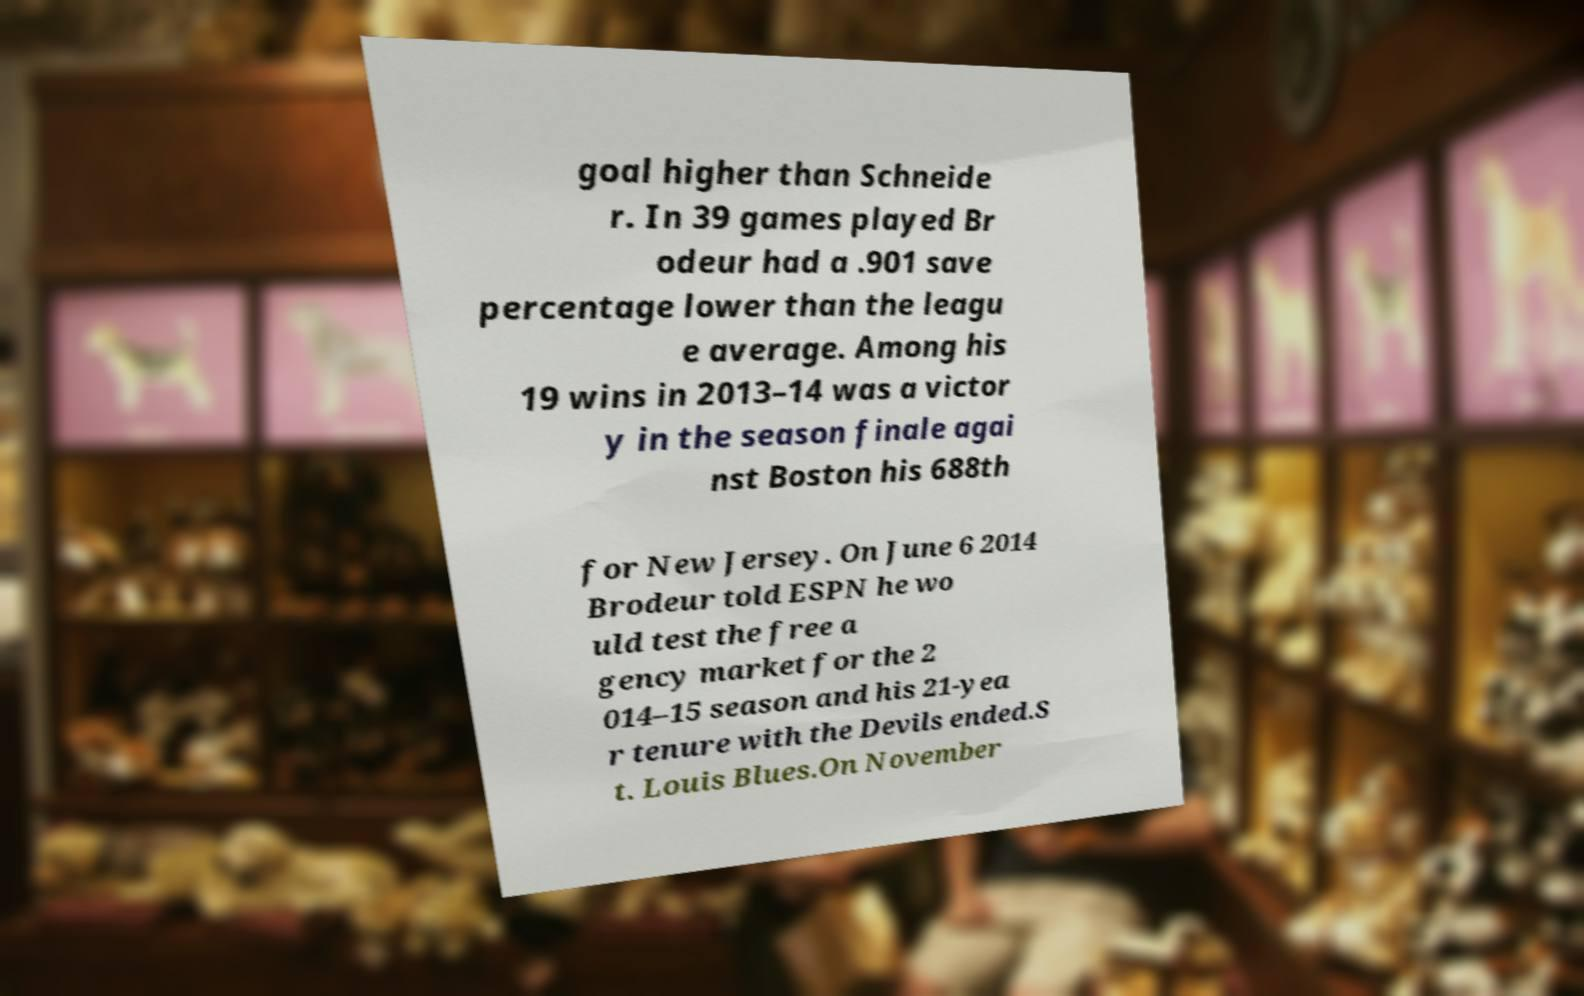Please identify and transcribe the text found in this image. goal higher than Schneide r. In 39 games played Br odeur had a .901 save percentage lower than the leagu e average. Among his 19 wins in 2013–14 was a victor y in the season finale agai nst Boston his 688th for New Jersey. On June 6 2014 Brodeur told ESPN he wo uld test the free a gency market for the 2 014–15 season and his 21-yea r tenure with the Devils ended.S t. Louis Blues.On November 